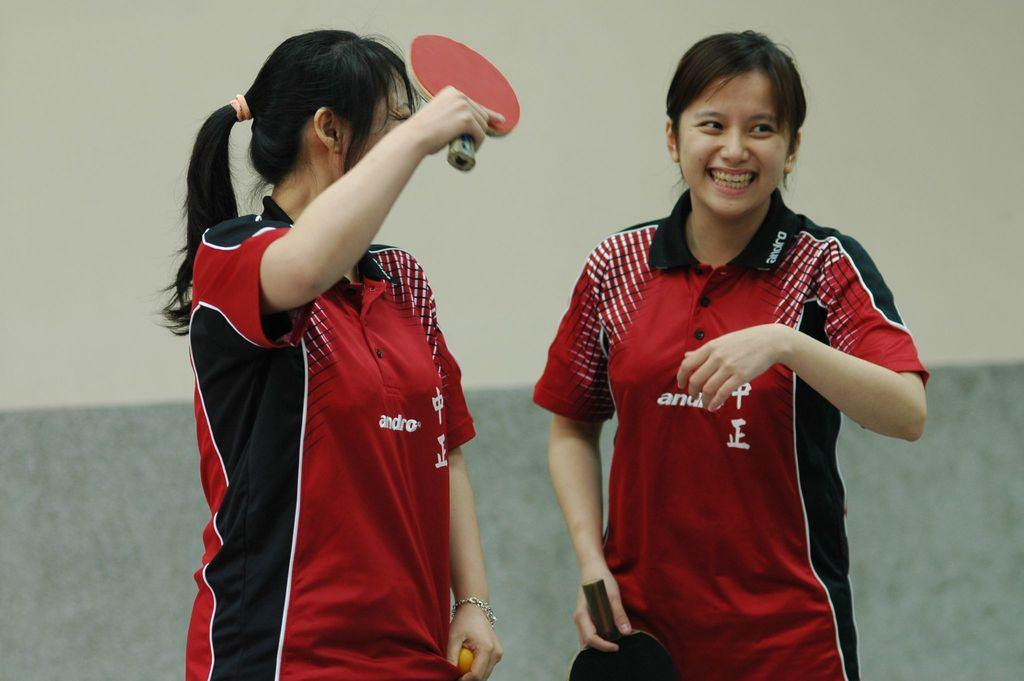How many people are in the image? There are two women in the image. What are the women doing in the image? The women are standing and smiling. What object is one of the women holding? One of the women is holding a bat. What can be seen in the background of the image? There is a wall in the background of the image. What type of needle is being used by one of the women in the image? There is no needle present in the image; one of the women is holding a bat. Is there a fire visible in the image? No, there is no fire visible in the image. 